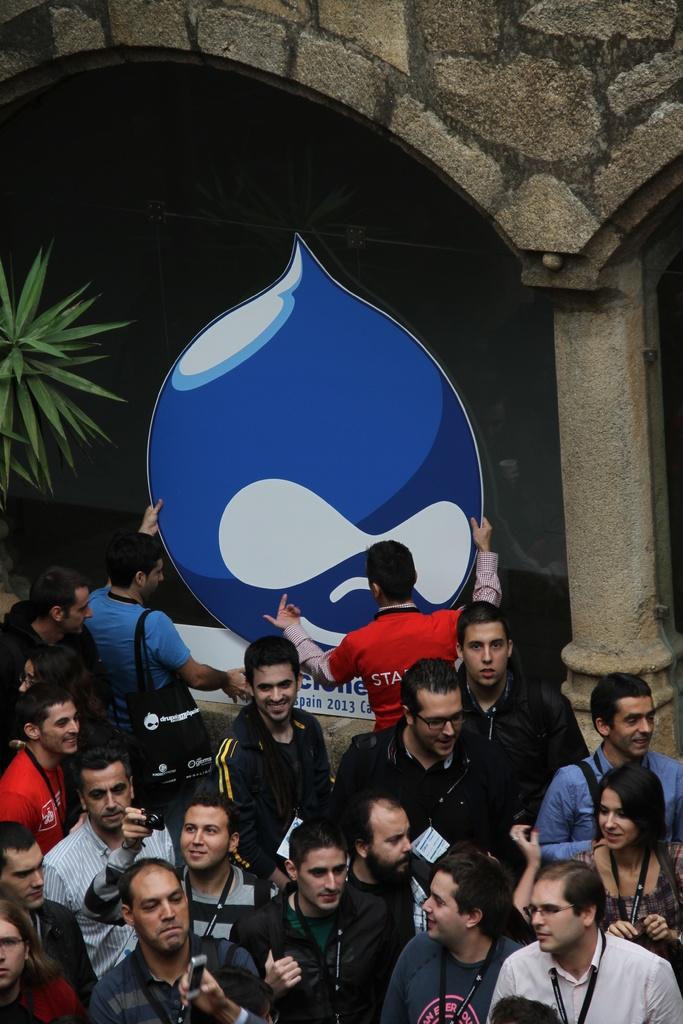How many people are present in the image? There are people in the image, but the exact number is not specified. What are some of the people holding in the image? Some of the people are holding objects, but the specific objects are not mentioned. What can be seen in the background of the image? In the background of the image, there is a plant, a pillar, and a wall. Can you see a feather floating in the air in the image? There is no mention of a feather in the image, so it cannot be confirmed or denied. Is there a button on the wall in the image? There is no mention of a button on the wall in the image, so it cannot be confirmed or denied. 